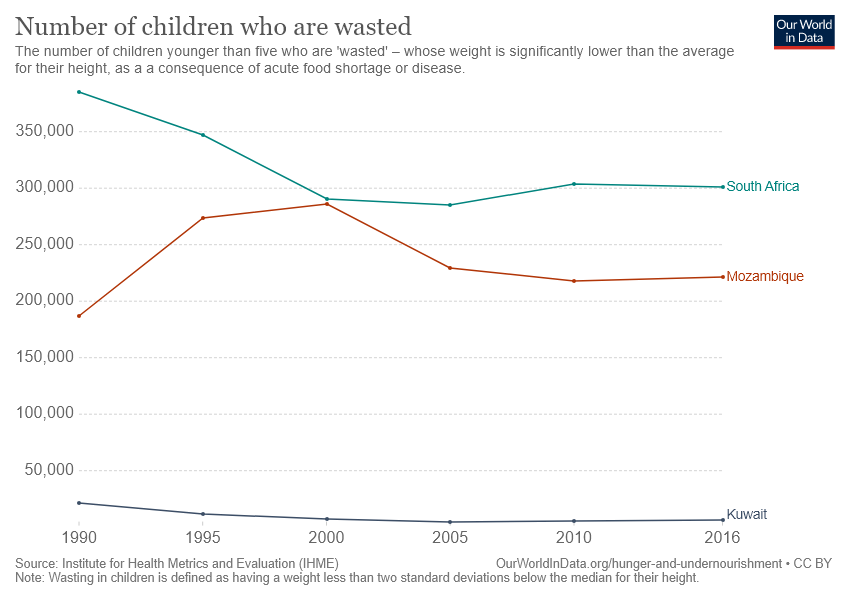Draw attention to some important aspects in this diagram. The country represented by the red color line is Mozambique. In 1990, the highest number of children who were wasted was recorded in South Africa. 